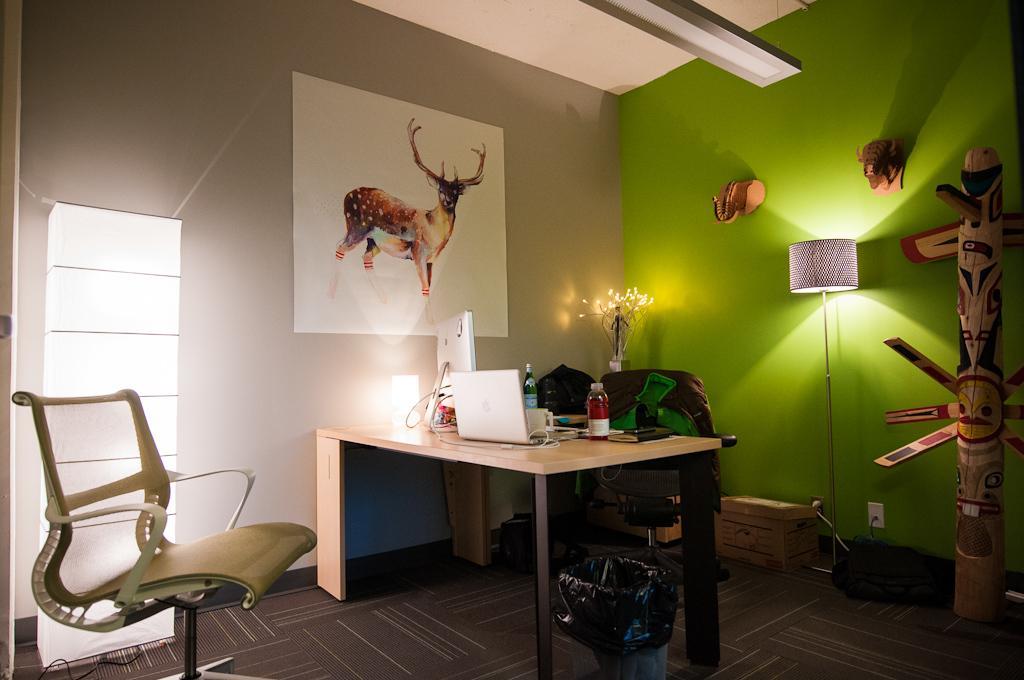In one or two sentences, can you explain what this image depicts? In this image we can see a table with some objects on it. In the background of the image there is wall. There is a poster of a animal on it. To the right side of the image there is an object. There are depictions of elephants on the wall. There is a light lamp. To the left side of the image there is chair. At the bottom of the image there is carpet. 